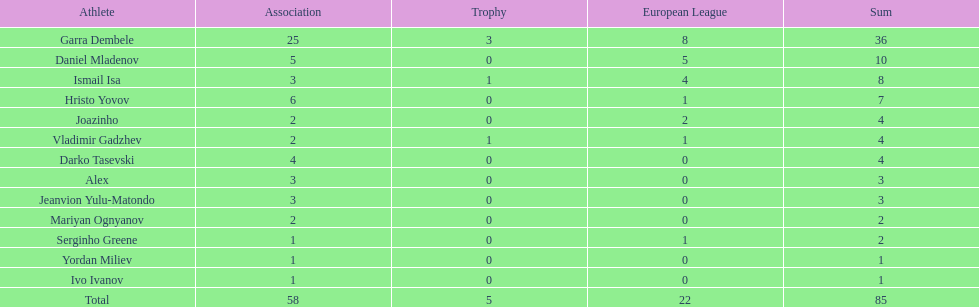What number of players in the cup didn't manage to score any goals? 10. Help me parse the entirety of this table. {'header': ['Athlete', 'Association', 'Trophy', 'European League', 'Sum'], 'rows': [['Garra Dembele', '25', '3', '8', '36'], ['Daniel Mladenov', '5', '0', '5', '10'], ['Ismail Isa', '3', '1', '4', '8'], ['Hristo Yovov', '6', '0', '1', '7'], ['Joazinho', '2', '0', '2', '4'], ['Vladimir Gadzhev', '2', '1', '1', '4'], ['Darko Tasevski', '4', '0', '0', '4'], ['Alex', '3', '0', '0', '3'], ['Jeanvion Yulu-Matondo', '3', '0', '0', '3'], ['Mariyan Ognyanov', '2', '0', '0', '2'], ['Serginho Greene', '1', '0', '1', '2'], ['Yordan Miliev', '1', '0', '0', '1'], ['Ivo Ivanov', '1', '0', '0', '1'], ['Total', '58', '5', '22', '85']]} 